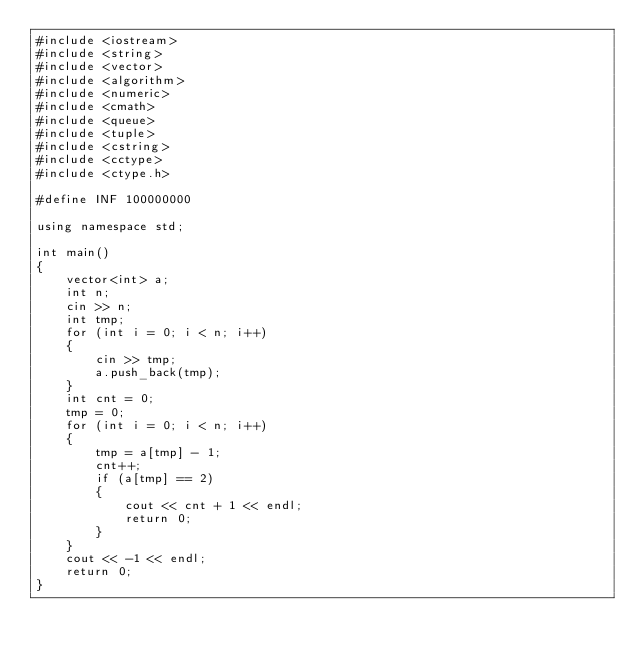<code> <loc_0><loc_0><loc_500><loc_500><_C++_>#include <iostream>
#include <string>
#include <vector>
#include <algorithm>
#include <numeric>
#include <cmath>
#include <queue>
#include <tuple>
#include <cstring>
#include <cctype>
#include <ctype.h>

#define INF 100000000

using namespace std;

int main()
{
    vector<int> a;
    int n;
    cin >> n;
    int tmp;
    for (int i = 0; i < n; i++)
    {
        cin >> tmp;
        a.push_back(tmp);
    }
    int cnt = 0;
    tmp = 0;
    for (int i = 0; i < n; i++)
    {
        tmp = a[tmp] - 1;
        cnt++;
        if (a[tmp] == 2)
        {
            cout << cnt + 1 << endl;
            return 0;
        }
    }
    cout << -1 << endl;
    return 0;
}
</code> 